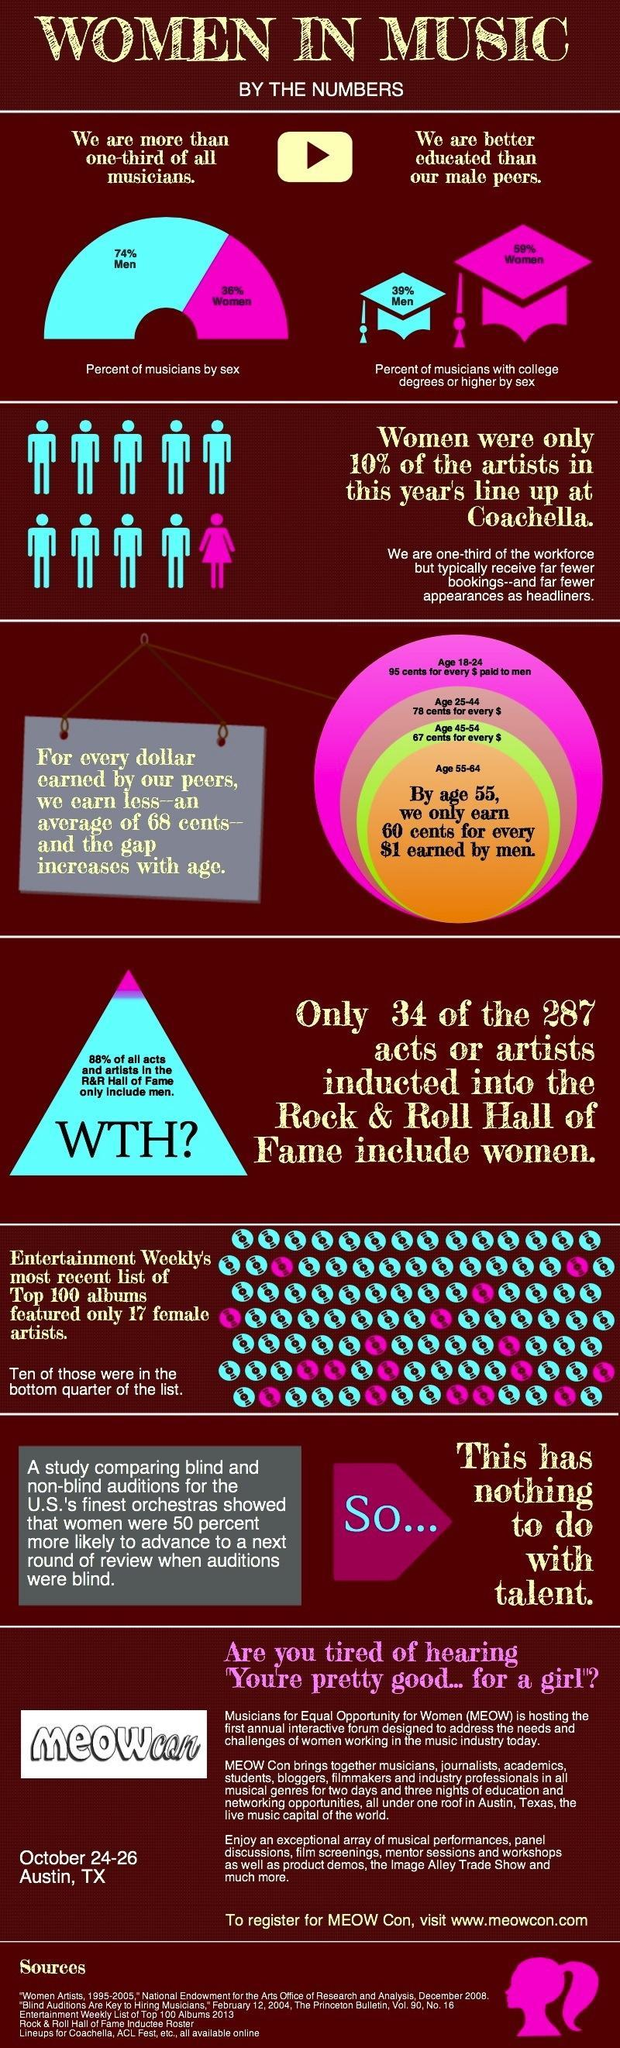What percent of musicians who own a college degree or higher are women?
Answer the question with a short phrase. 59% What percentage of musicians are men? 74% 